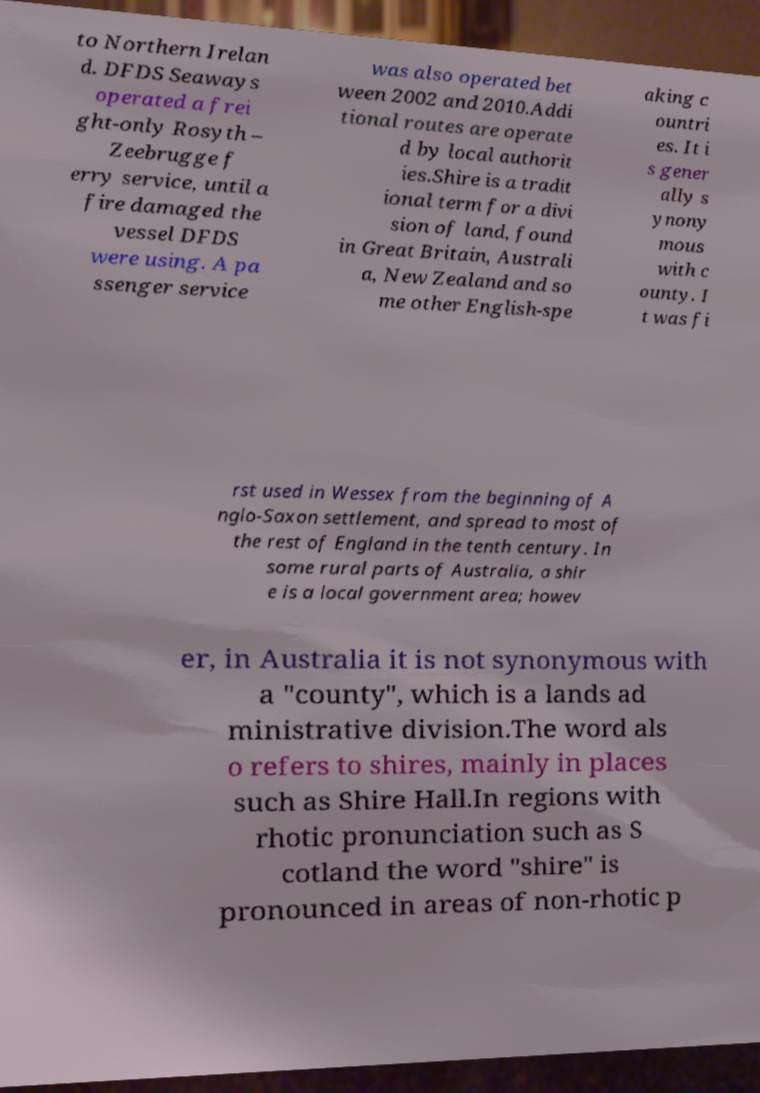For documentation purposes, I need the text within this image transcribed. Could you provide that? to Northern Irelan d. DFDS Seaways operated a frei ght-only Rosyth – Zeebrugge f erry service, until a fire damaged the vessel DFDS were using. A pa ssenger service was also operated bet ween 2002 and 2010.Addi tional routes are operate d by local authorit ies.Shire is a tradit ional term for a divi sion of land, found in Great Britain, Australi a, New Zealand and so me other English-spe aking c ountri es. It i s gener ally s ynony mous with c ounty. I t was fi rst used in Wessex from the beginning of A nglo-Saxon settlement, and spread to most of the rest of England in the tenth century. In some rural parts of Australia, a shir e is a local government area; howev er, in Australia it is not synonymous with a "county", which is a lands ad ministrative division.The word als o refers to shires, mainly in places such as Shire Hall.In regions with rhotic pronunciation such as S cotland the word "shire" is pronounced in areas of non-rhotic p 